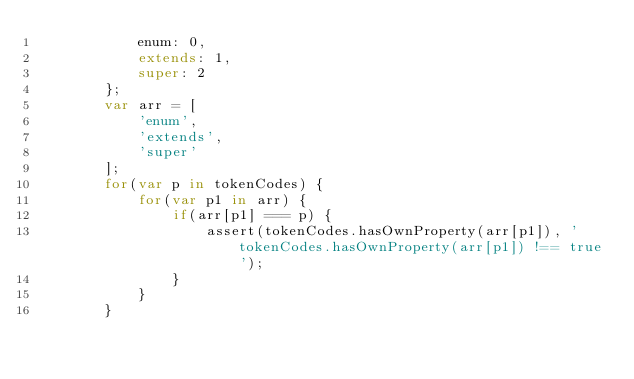<code> <loc_0><loc_0><loc_500><loc_500><_JavaScript_>            enum: 0,
            extends: 1,
            super: 2
        };
        var arr = [
            'enum',
            'extends',
            'super'
        ];        
        for(var p in tokenCodes) {
            for(var p1 in arr) {
                if(arr[p1] === p) {                     
                    assert(tokenCodes.hasOwnProperty(arr[p1]), 'tokenCodes.hasOwnProperty(arr[p1]) !== true');
                }
            }
        }
</code> 